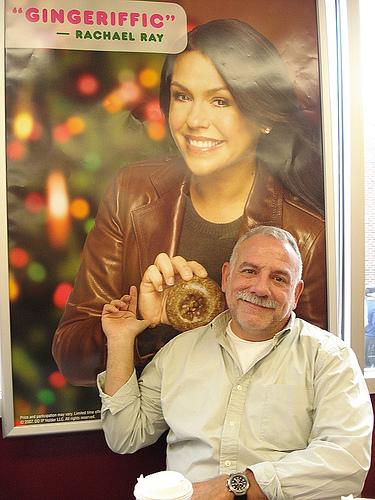What is on his left wrist?
Concise answer only. Watch. What is the figure holding?
Write a very short answer. Donut. Who is quoted in the image?
Give a very brief answer. Rachael ray. What is Rachel Ray Holding?
Keep it brief. Donut. What food is on top of the donut?
Short answer required. Ginger. What is the man wearing on his face?
Short answer required. Mustache. 